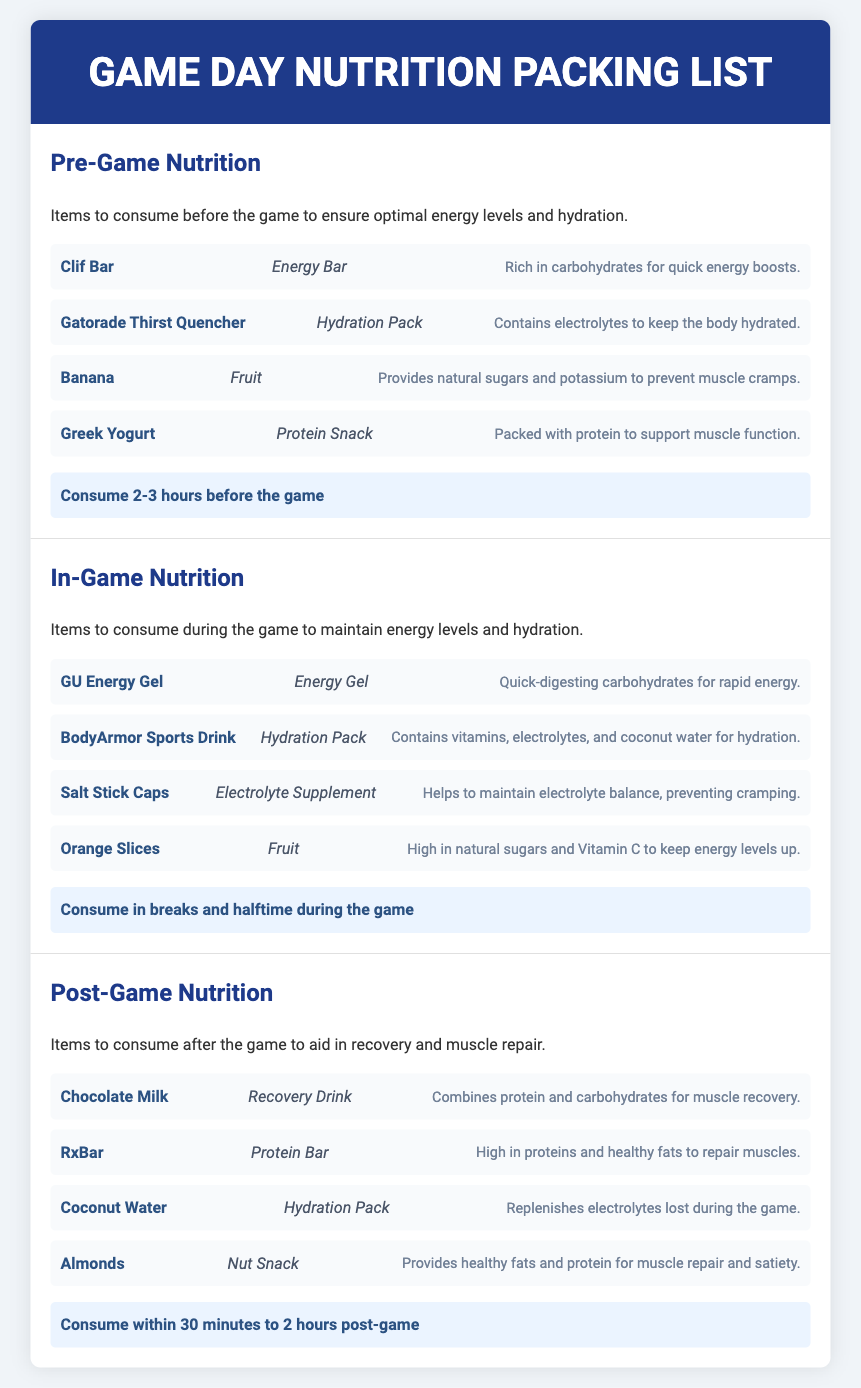What are the items to consume in-game? The document lists specific items, including GU Energy Gel, BodyArmor Sports Drink, Salt Stick Caps, and Orange Slices, for in-game consumption.
Answer: GU Energy Gel, BodyArmor Sports Drink, Salt Stick Caps, Orange Slices How long before the game should you consume pre-game nutrition? The document states to consume pre-game nutrition 2-3 hours before the game.
Answer: 2-3 hours Which item provides natural sugars and potassium? The document mentions Banana as the item that provides natural sugars and potassium.
Answer: Banana What type of nutrition item is Chocolate Milk categorized as? According to the document, Chocolate Milk is categorized as a Recovery Drink.
Answer: Recovery Drink How long after the game should you consume post-game nutrition? The document indicates to consume post-game nutrition within 30 minutes to 2 hours post-game.
Answer: 30 minutes to 2 hours What is the purpose of the Greek Yogurt in pre-game nutrition? The document notes that Greek Yogurt is packed with protein to support muscle function.
Answer: Support muscle function Which electrolyte supplement is listed in the in-game nutrition? Salt Stick Caps are identified as the electrolyte supplement in the in-game nutrition section.
Answer: Salt Stick Caps How many types of fruits are mentioned in the pre-game nutrition? There are two types of fruits mentioned: Banana and Orange Slices, one from pre-game and one from in-game.
Answer: 2 types What does Almonds provide in post-game nutrition? The document states that Almonds provide healthy fats and protein for muscle repair and satiety.
Answer: Healthy fats and protein 